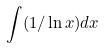<formula> <loc_0><loc_0><loc_500><loc_500>\int ( 1 / \ln x ) d x</formula> 